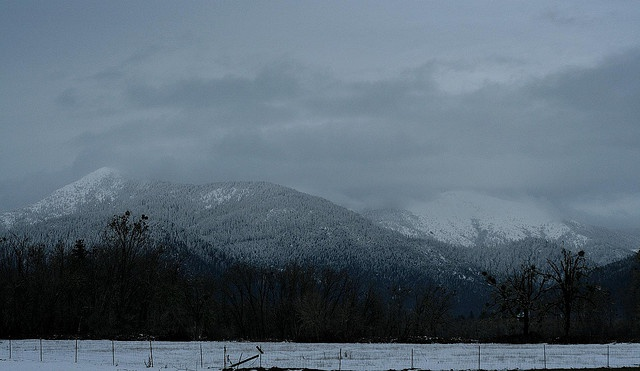Describe the objects in this image and their specific colors. I can see various objects in this image with different colors. 